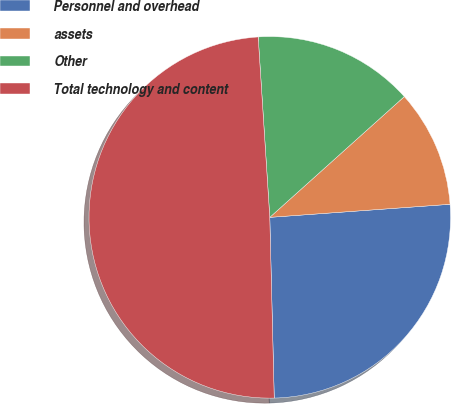Convert chart to OTSL. <chart><loc_0><loc_0><loc_500><loc_500><pie_chart><fcel>Personnel and overhead<fcel>assets<fcel>Other<fcel>Total technology and content<nl><fcel>25.76%<fcel>10.49%<fcel>14.38%<fcel>49.37%<nl></chart> 